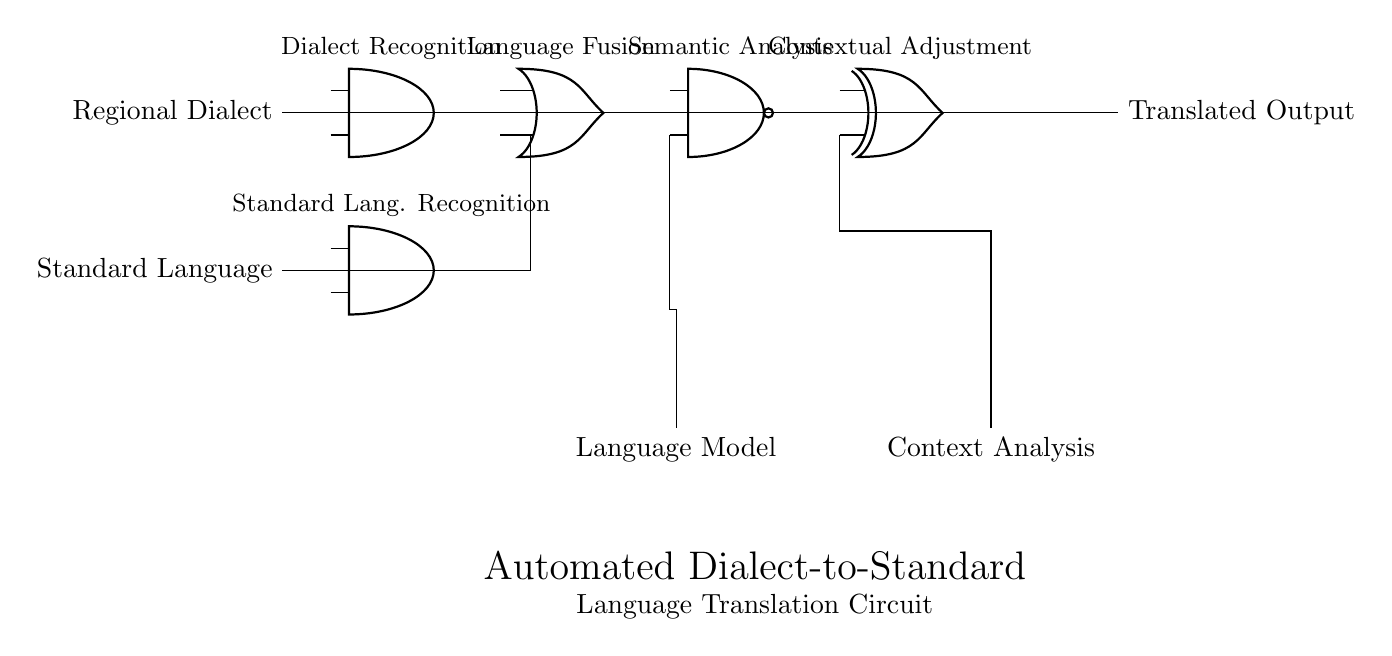What are the input signals in this circuit? The diagram shows two input signals: 'Regional Dialect' and 'Standard Language'. These are the signals entering the circuit for processing.
Answer: Regional Dialect and Standard Language What type of logic gate is used for Language Fusion? The Language Fusion component is represented by an OR gate, which combines inputs from the dialect and standard language recognitions.
Answer: OR gate What is the function of the Semantic Analysis stage? Semantic Analysis is performed using a NAND gate, which processes outputs from the Language Fusion and a Language Model for determining the meaning.
Answer: NAND gate How many logic gates are there in total? The circuit includes five gates: two AND gates, one OR gate, one NAND gate, and one XOR gate. Counting each type gives a total of five.
Answer: Five What is the final output of the circuit? The final output of the circuit is labeled as 'Translated Output', indicating the result after processing through various stages.
Answer: Translated Output What does the Contextual Adjustment stage do? The Context Adjustment component uses an XOR gate, which helps refine the translated output based on context analysis to ensure accuracy in translation.
Answer: XOR gate 